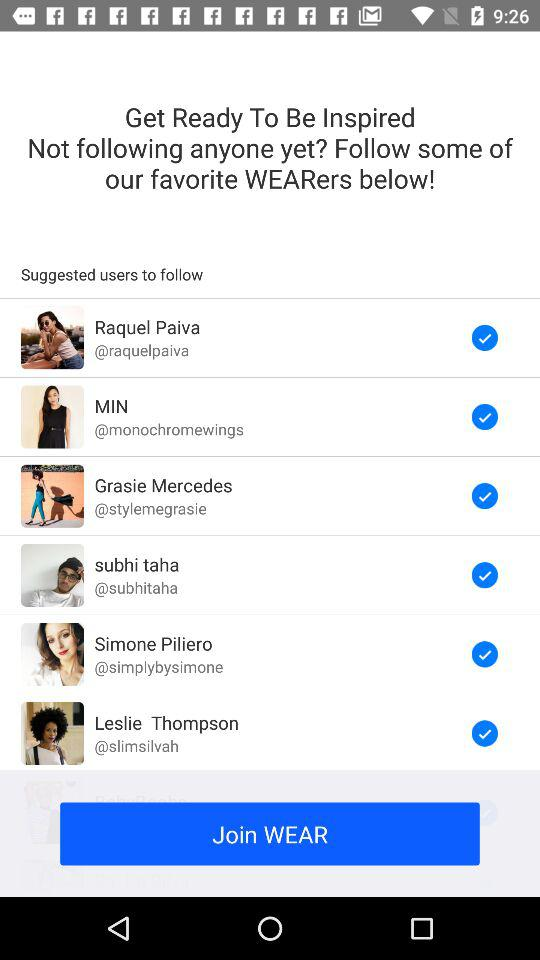How many users are suggested to follow?
Answer the question using a single word or phrase. 6 